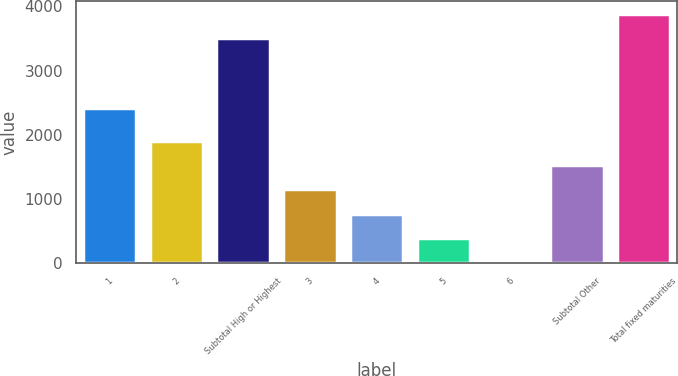<chart> <loc_0><loc_0><loc_500><loc_500><bar_chart><fcel>1<fcel>2<fcel>Subtotal High or Highest<fcel>3<fcel>4<fcel>5<fcel>6<fcel>Subtotal Other<fcel>Total fixed maturities<nl><fcel>2425<fcel>1910<fcel>3506<fcel>1150.4<fcel>770.6<fcel>390.8<fcel>11<fcel>1530.2<fcel>3885.8<nl></chart> 